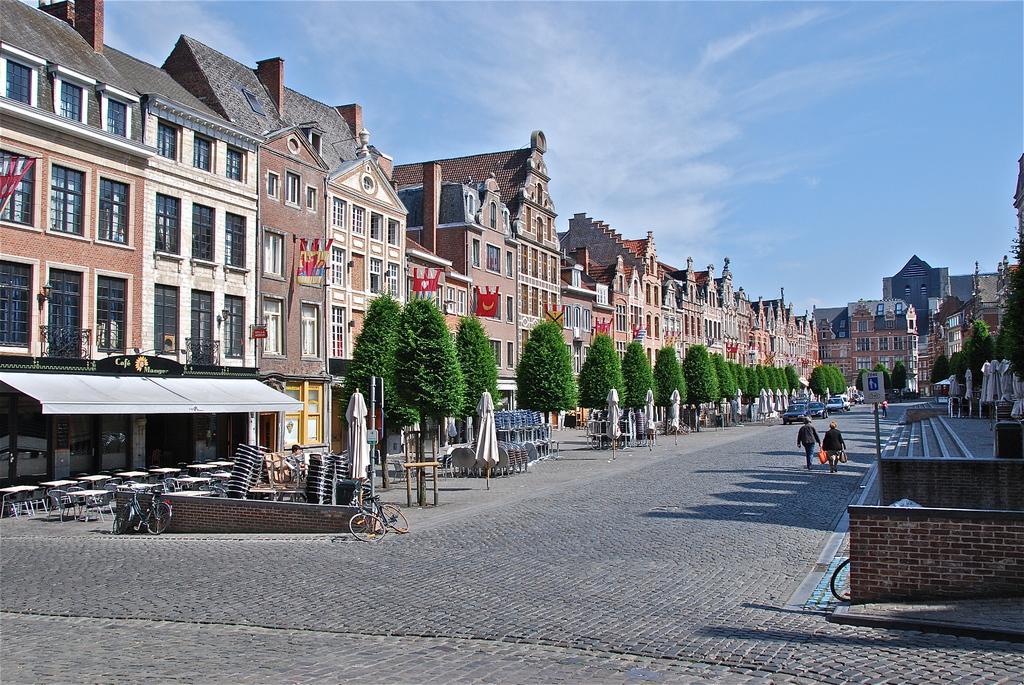Describe this image in one or two sentences. There is a road. Through the road some people are walking. On the side of the road there are steps. On the left side there are trees, umbrellas, chairs, cycles, buildings with windows. On the building there are flags. In the background there is sky. 